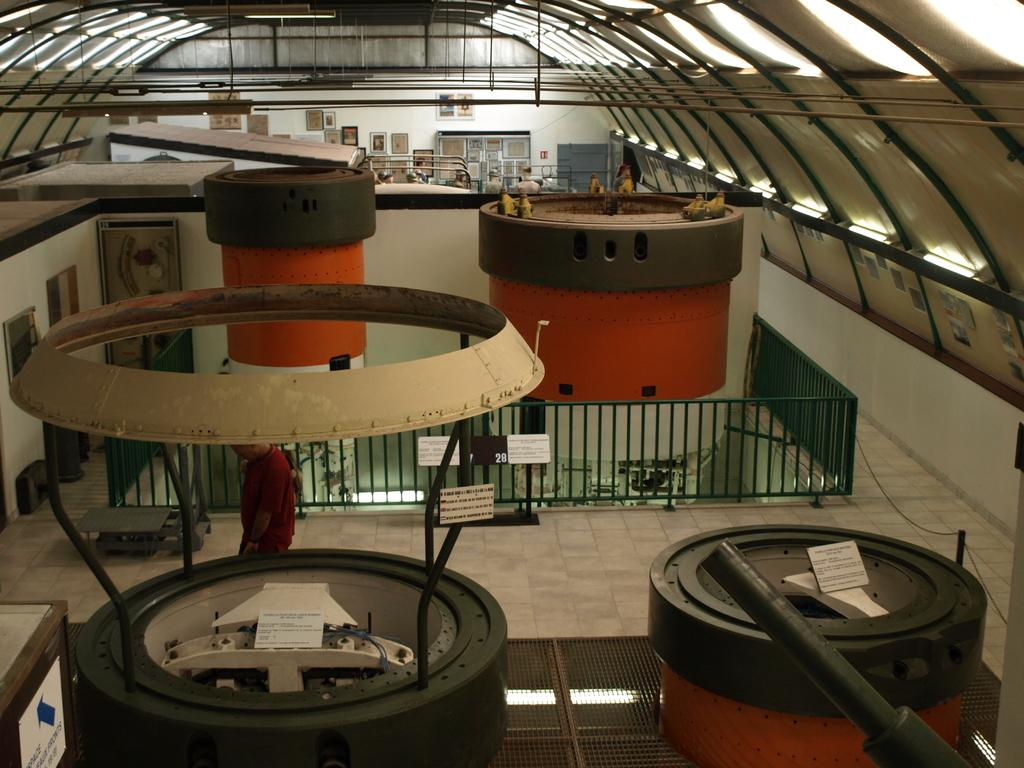What objects can be seen in the image that are used for storage or containment? There are containers in the image. What objects can be seen in the image that are used for display or support? There are boards in the image. What structure can be seen in the image that separates or encloses an area? There is a fence in the image. What surface can be seen in the image that people walk on? There is a floor in the image. What structures can be seen in the image that enclose or surround a space? There are walls in the image. What objects can be seen in the image that provide illumination? There are lights in the image. What structure can be seen in the image that covers and protects the top of a building or space? There is a roof in the image. Who or what can be seen in the image? There are people in the image. What type of vest is being worn by the people in the image? There is no mention of a vest in the image, so it cannot be determined if anyone is wearing one. What experience can be gained by observing the people in the image? The image does not provide any information about the people's experiences, so it cannot be determined what experience might be gained by observing them. 